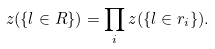Convert formula to latex. <formula><loc_0><loc_0><loc_500><loc_500>z ( \{ l \in R \} ) = \prod _ { i } z ( \{ l \in r _ { i } \} ) .</formula> 